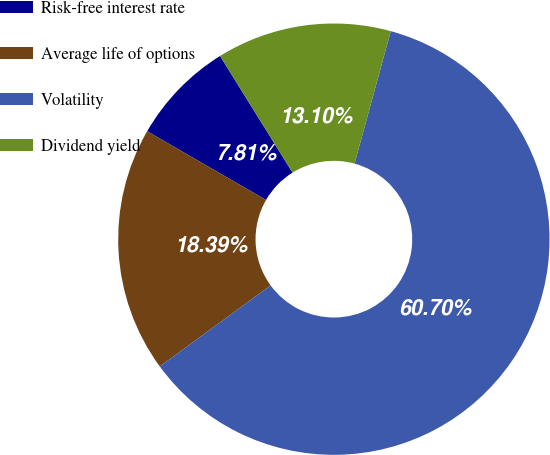Convert chart to OTSL. <chart><loc_0><loc_0><loc_500><loc_500><pie_chart><fcel>Risk-free interest rate<fcel>Average life of options<fcel>Volatility<fcel>Dividend yield<nl><fcel>7.81%<fcel>18.39%<fcel>60.71%<fcel>13.1%<nl></chart> 